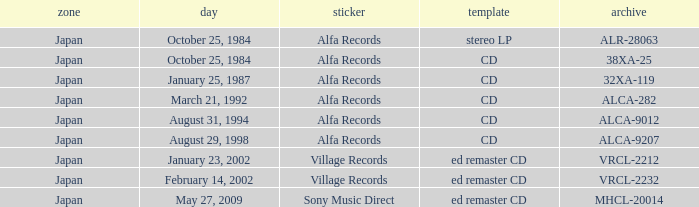What is the region of the Alfa Records release with catalog ALCA-282? Japan. 